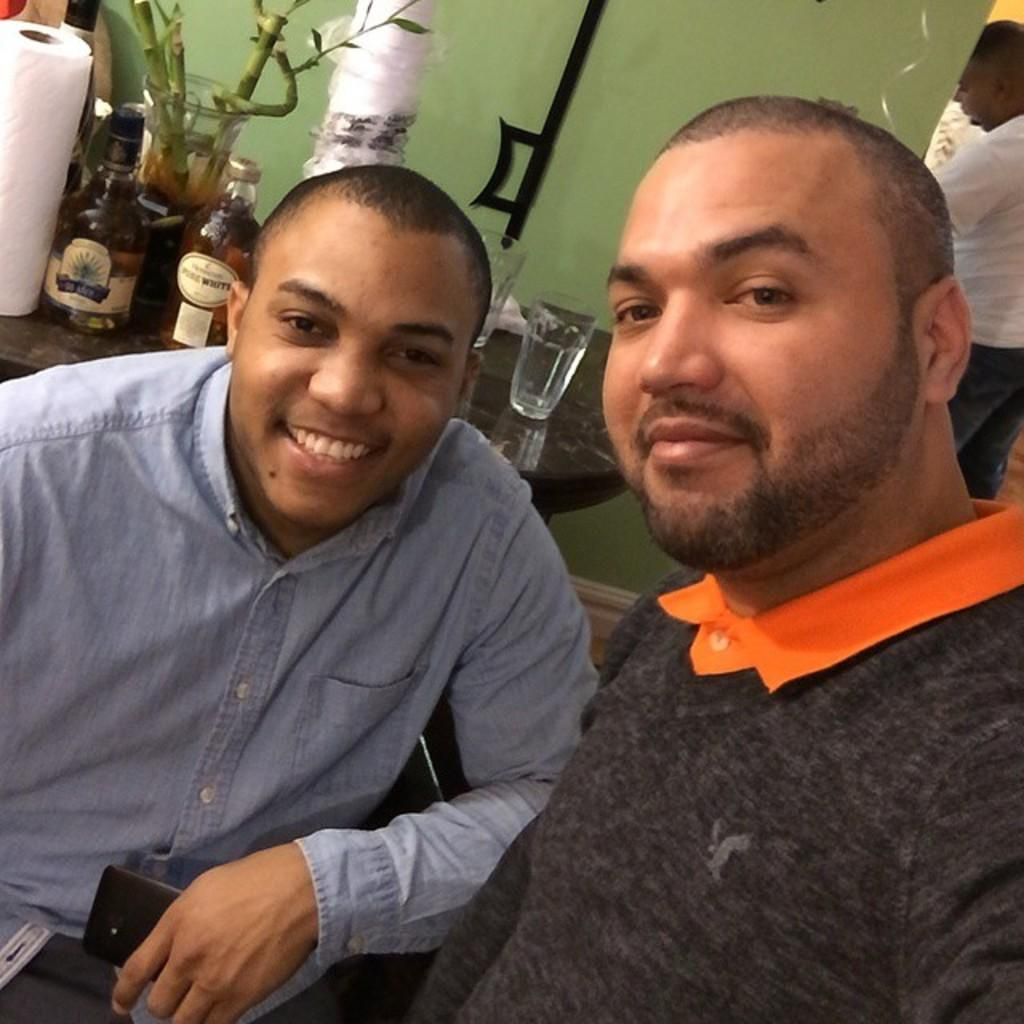How many people are in the image? There are two men in the image. What are the men doing in the image? The men are seated and smiling. What is present on the table in the image? There are wine bottles and glasses on the table. What type of breakfast is being served on the table in the image? There is no breakfast visible in the image; it features two men seated with wine bottles and glasses on the table. 